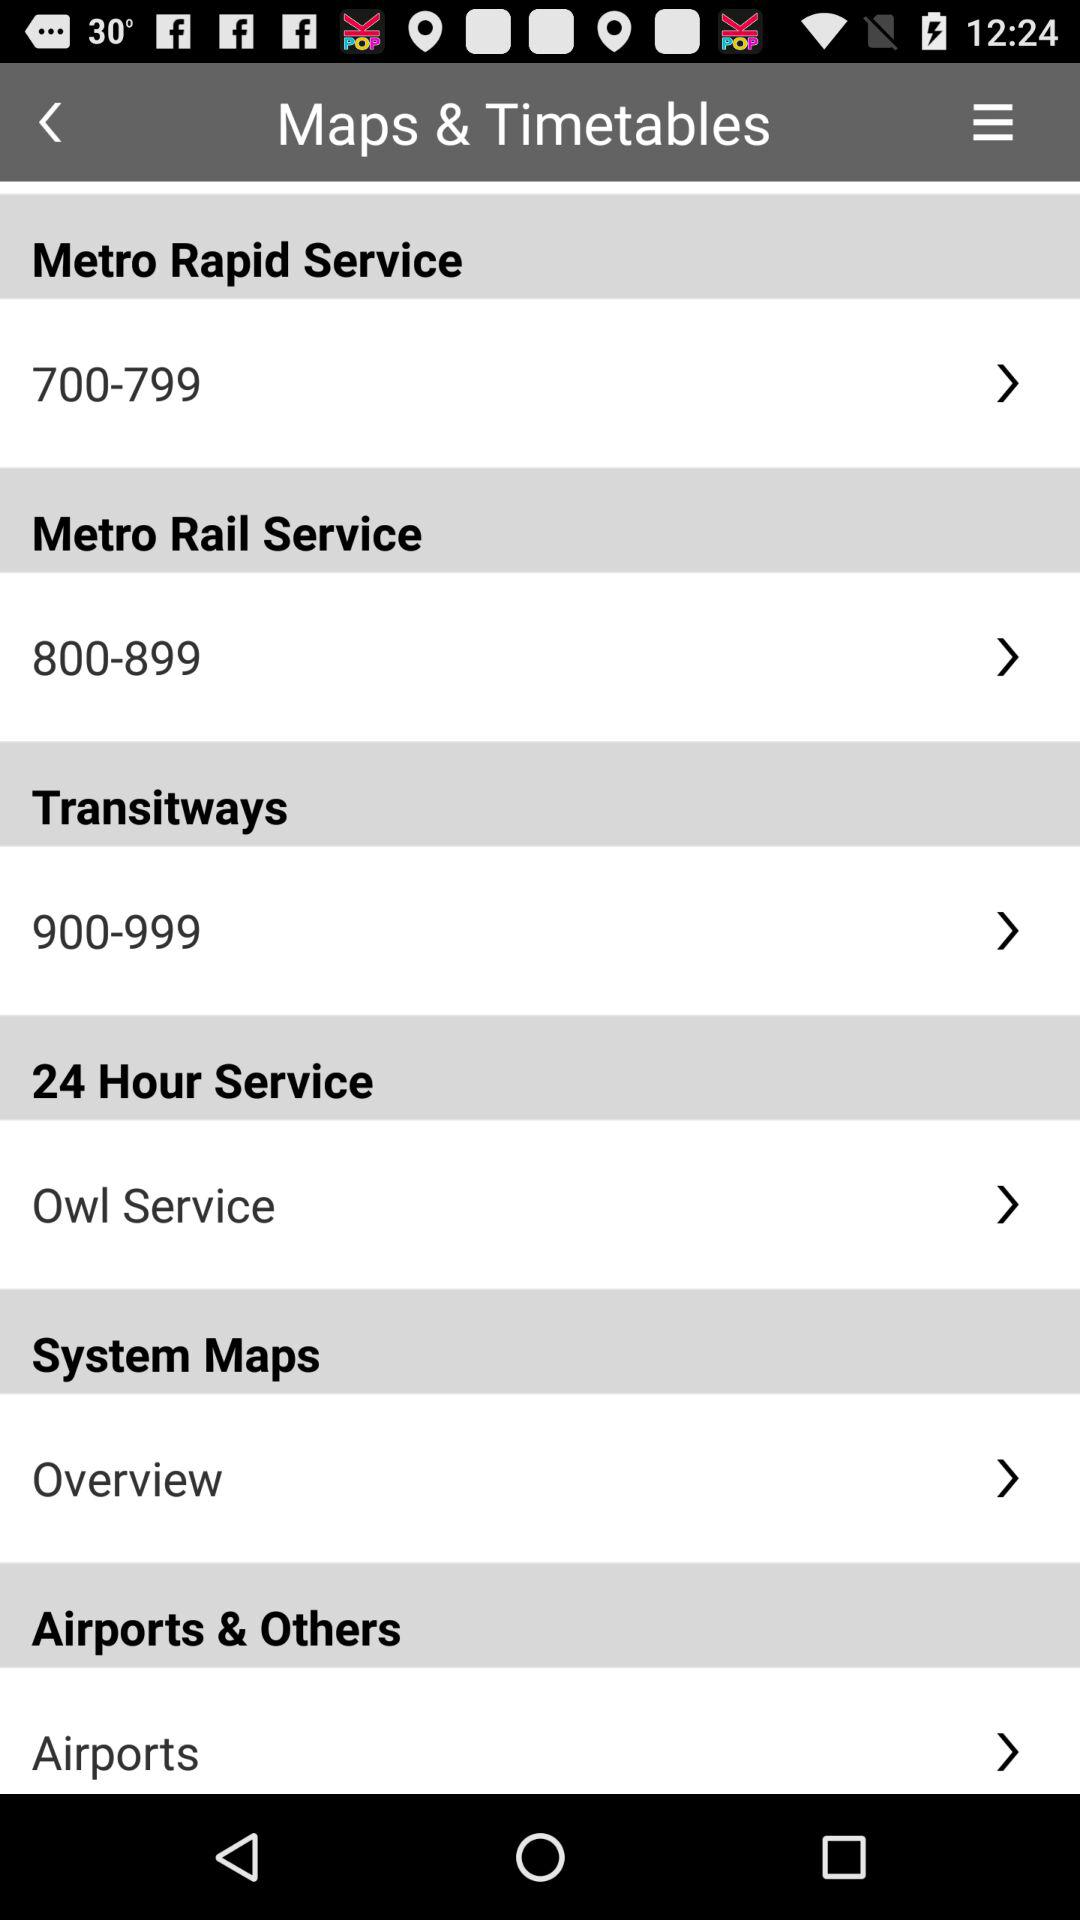Which category does 900–999 belong to? It belongs to "Transitways" category. 